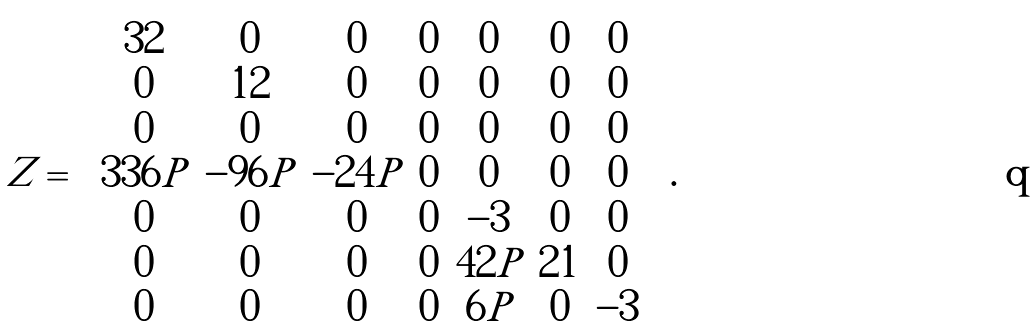Convert formula to latex. <formula><loc_0><loc_0><loc_500><loc_500>Z = \begin{pmatrix} 3 2 & 0 & 0 & 0 & 0 & 0 & 0 \\ 0 & 1 2 & 0 & 0 & 0 & 0 & 0 \\ 0 & 0 & 0 & 0 & 0 & 0 & 0 \\ 3 3 6 P & - 9 6 P & - 2 4 P & 0 & 0 & 0 & 0 \\ 0 & 0 & 0 & 0 & - 3 & 0 & 0 \\ 0 & 0 & 0 & 0 & 4 2 P & 2 1 & 0 \\ 0 & 0 & 0 & 0 & 6 P & 0 & - 3 \end{pmatrix} .</formula> 